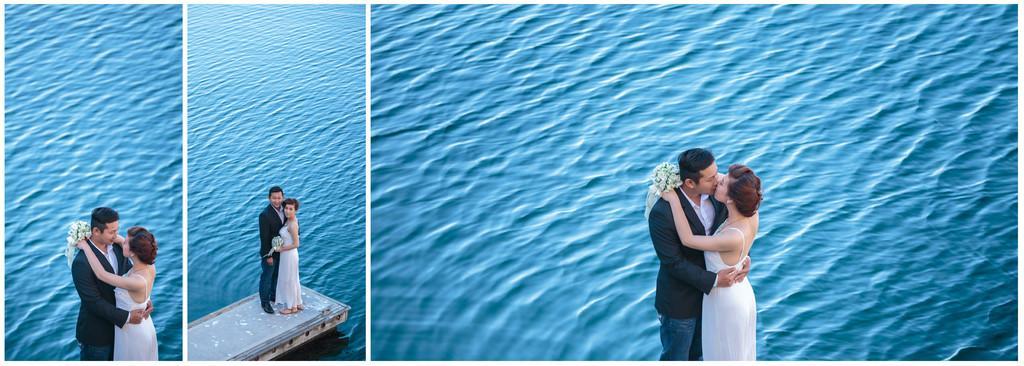In one or two sentences, can you explain what this image depicts? In this image I can see there are three couples standing on the edge of a bridge , in the background I can see water. 